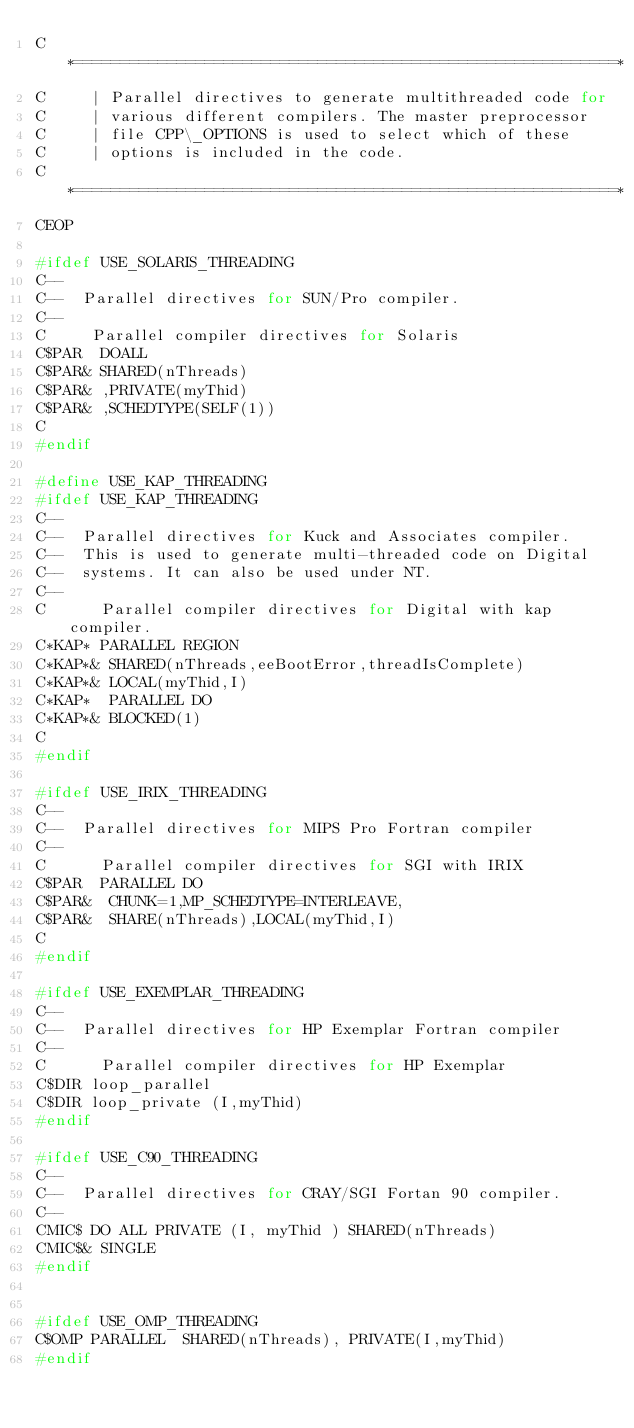Convert code to text. <code><loc_0><loc_0><loc_500><loc_500><_C_>C     *==========================================================*
C     | Parallel directives to generate multithreaded code for    
C     | various different compilers. The master preprocessor      
C     | file CPP\_OPTIONS is used to select which of these 
C     | options is included in the code.
C     *==========================================================*
CEOP

#ifdef USE_SOLARIS_THREADING
C--
C--  Parallel directives for SUN/Pro compiler.
C--
C     Parallel compiler directives for Solaris
C$PAR  DOALL
C$PAR& SHARED(nThreads)
C$PAR& ,PRIVATE(myThid)
C$PAR& ,SCHEDTYPE(SELF(1))
C
#endif

#define USE_KAP_THREADING
#ifdef USE_KAP_THREADING
C--
C--  Parallel directives for Kuck and Associates compiler.
C--  This is used to generate multi-threaded code on Digital 
C--  systems. It can also be used under NT.
C--
C      Parallel compiler directives for Digital with kap compiler.
C*KAP* PARALLEL REGION
C*KAP*& SHARED(nThreads,eeBootError,threadIsComplete)
C*KAP*& LOCAL(myThid,I)
C*KAP*  PARALLEL DO
C*KAP*& BLOCKED(1)
C
#endif

#ifdef USE_IRIX_THREADING
C--
C--  Parallel directives for MIPS Pro Fortran compiler
C--
C      Parallel compiler directives for SGI with IRIX
C$PAR  PARALLEL DO
C$PAR&  CHUNK=1,MP_SCHEDTYPE=INTERLEAVE,
C$PAR&  SHARE(nThreads),LOCAL(myThid,I)
C
#endif

#ifdef USE_EXEMPLAR_THREADING
C--
C--  Parallel directives for HP Exemplar Fortran compiler
C--
C      Parallel compiler directives for HP Exemplar
C$DIR loop_parallel
C$DIR loop_private (I,myThid)
#endif

#ifdef USE_C90_THREADING
C--
C--  Parallel directives for CRAY/SGI Fortan 90 compiler.
C--
CMIC$ DO ALL PRIVATE (I, myThid ) SHARED(nThreads)
CMIC$& SINGLE
#endif             


#ifdef USE_OMP_THREADING
C$OMP PARALLEL  SHARED(nThreads), PRIVATE(I,myThid)
#endif

</code> 